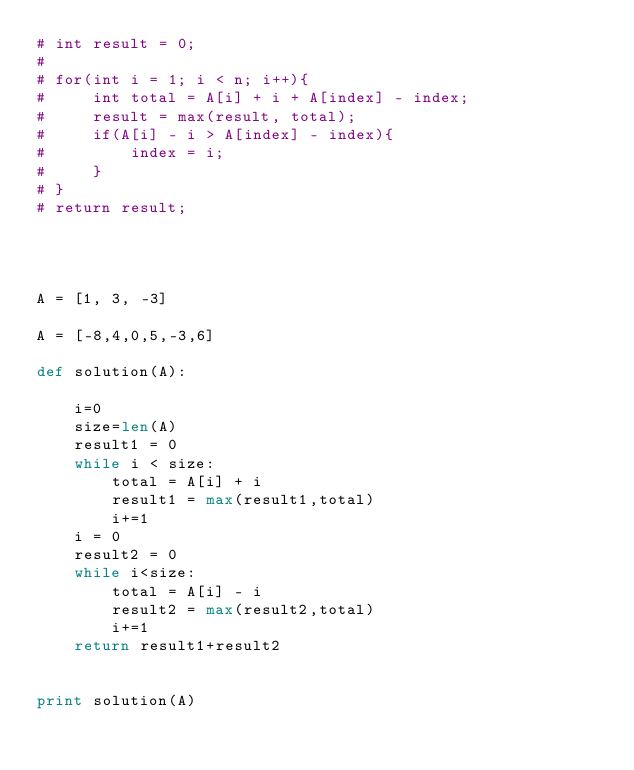<code> <loc_0><loc_0><loc_500><loc_500><_Python_># int result = 0;
#
# for(int i = 1; i < n; i++){
#     int total = A[i] + i + A[index] - index;
#     result = max(result, total);
#     if(A[i] - i > A[index] - index){
#         index = i;
#     }
# }
# return result;




A = [1, 3, -3]

A = [-8,4,0,5,-3,6]

def solution(A):

    i=0
    size=len(A)
    result1 = 0
    while i < size:
        total = A[i] + i
        result1 = max(result1,total)
        i+=1
    i = 0
    result2 = 0
    while i<size:
        total = A[i] - i
        result2 = max(result2,total)
        i+=1
    return result1+result2


print solution(A)</code> 